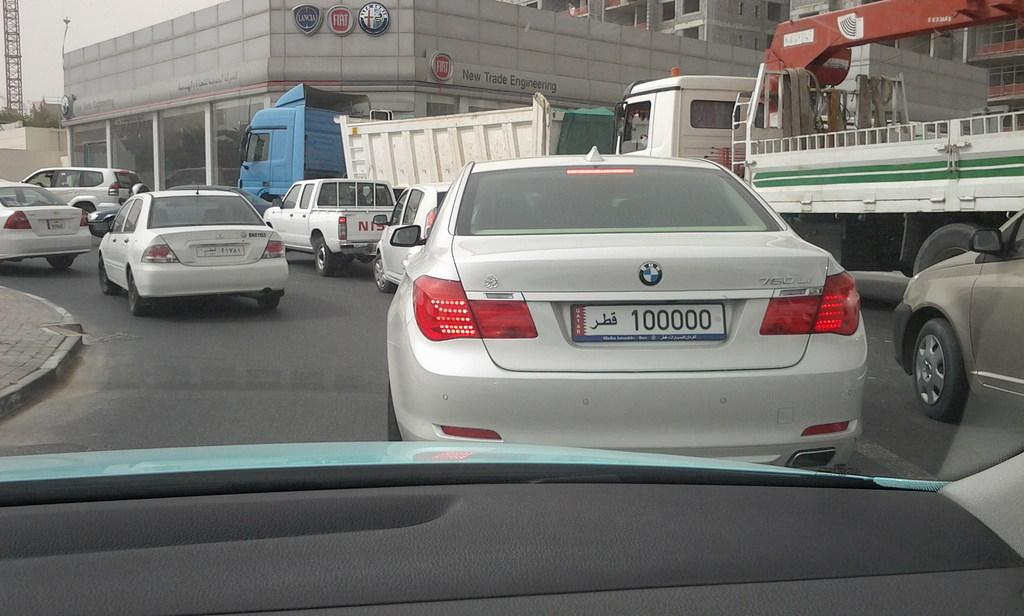<image>
Summarize the visual content of the image. A white BMW that has the numbers 100000 on the license plate drives amongst several other vehicles. 